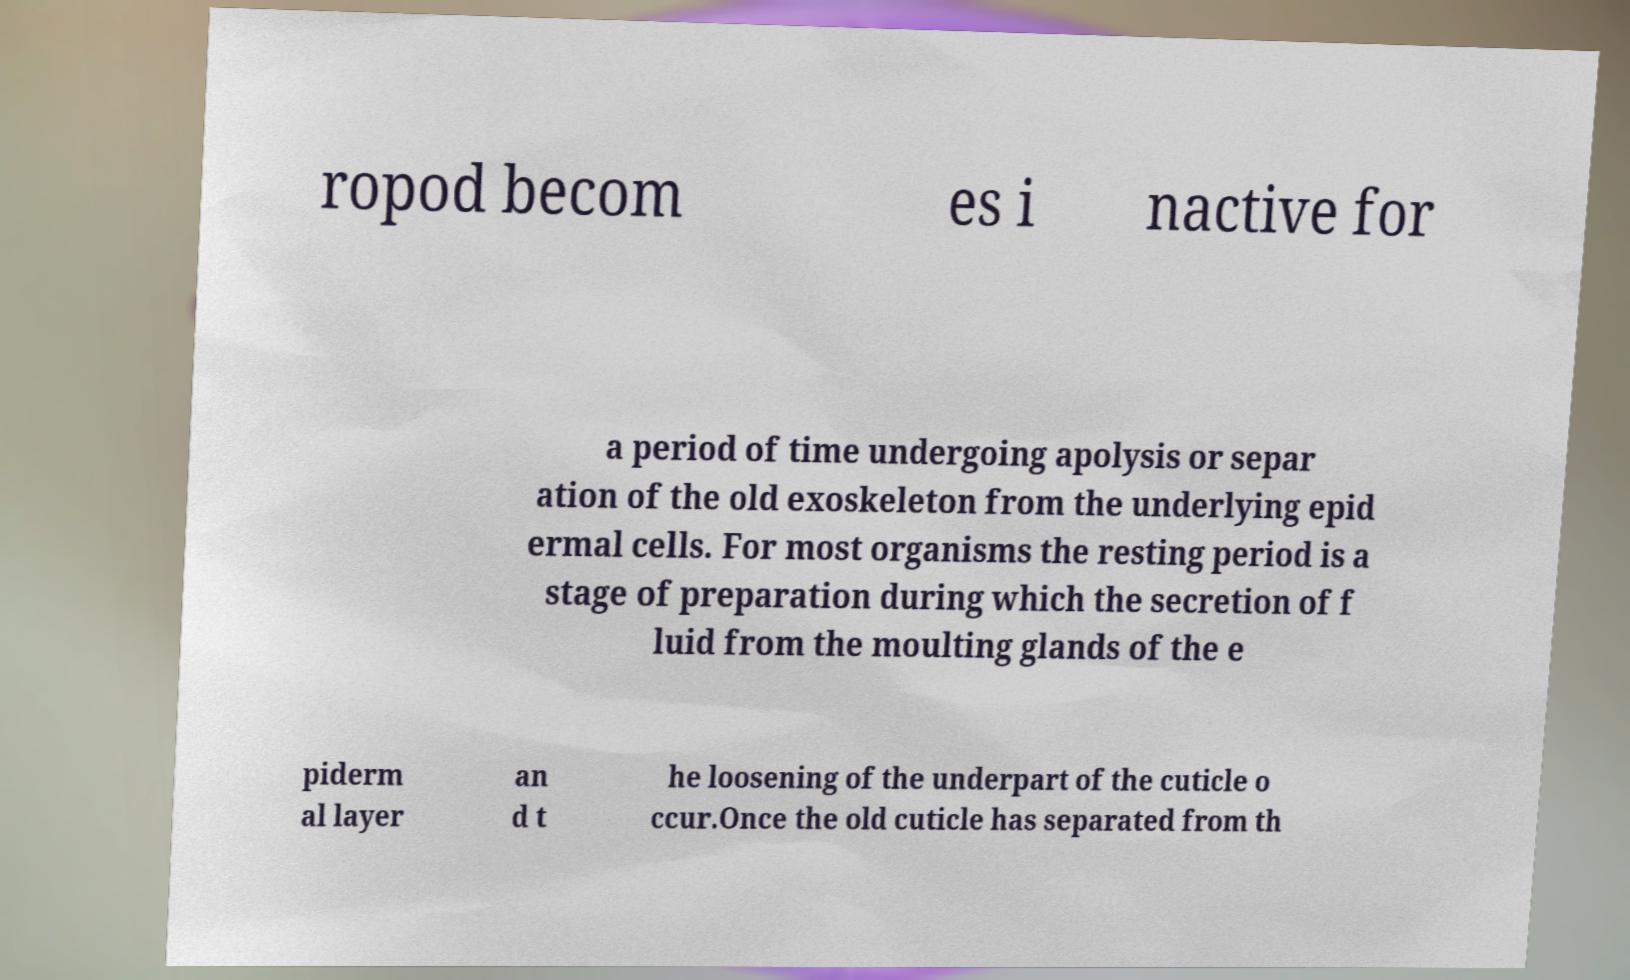Please read and relay the text visible in this image. What does it say? ropod becom es i nactive for a period of time undergoing apolysis or separ ation of the old exoskeleton from the underlying epid ermal cells. For most organisms the resting period is a stage of preparation during which the secretion of f luid from the moulting glands of the e piderm al layer an d t he loosening of the underpart of the cuticle o ccur.Once the old cuticle has separated from th 